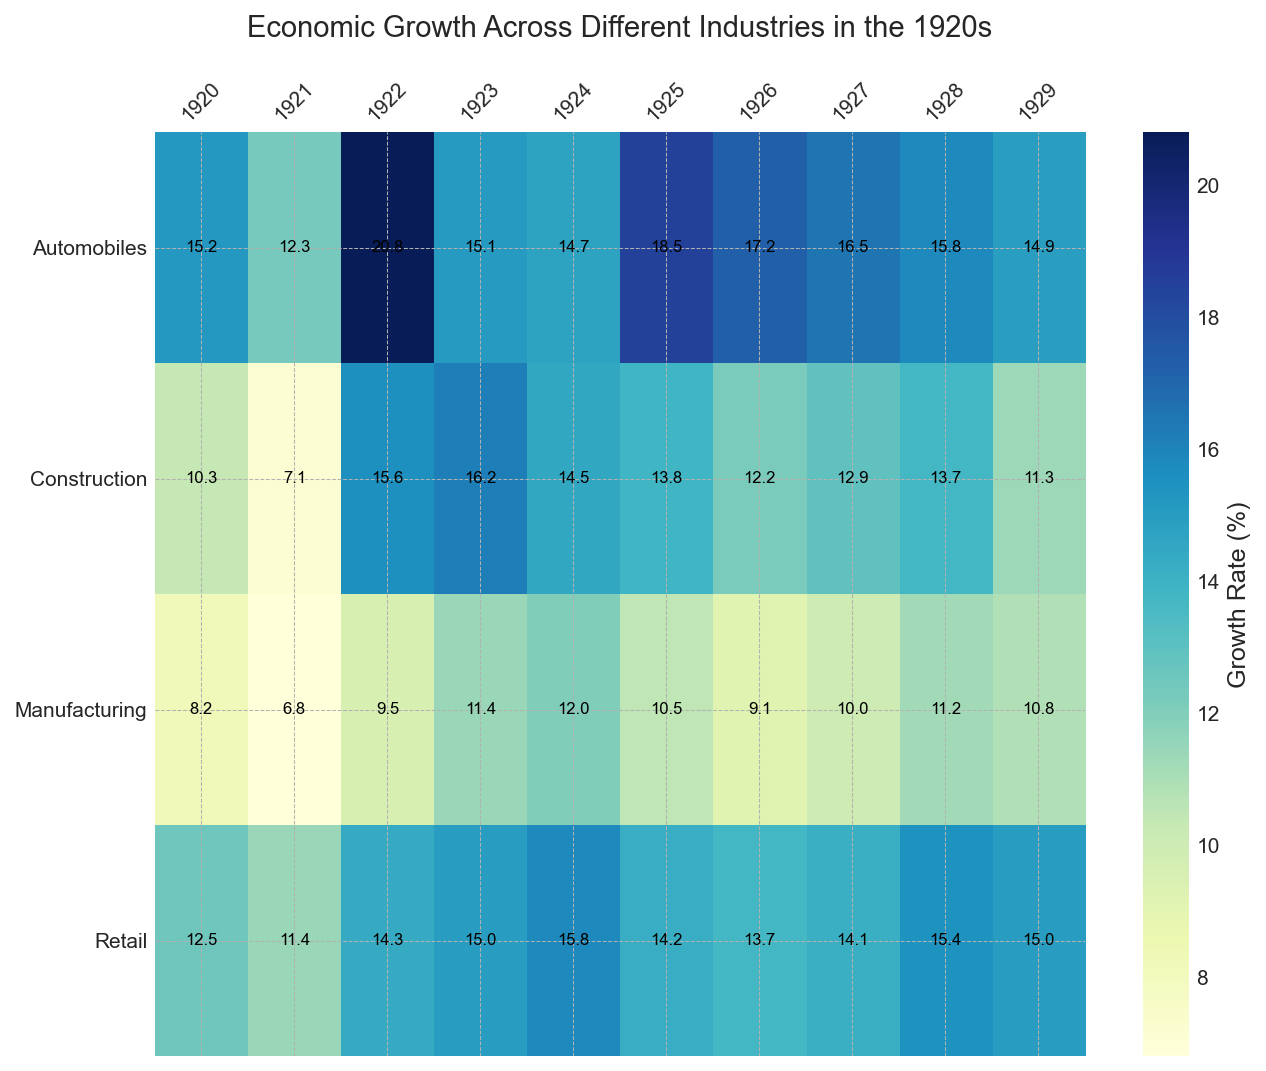Which industry had the highest growth rate in 1923? Look at the 1923 column and find the highest value. The highest growth rate in 1923 is in Construction with 16.2%.
Answer: Construction What was the total growth rate for the Automobiles industry from 1925 to 1929? Sum up the growth rates for the Automobiles industry from 1925 (18.5%) to 1929 (14.9%). The total growth rate is 18.5 + 17.2 + 16.5 + 15.8 + 14.9 = 82.9%.
Answer: 82.9% Which industry had the most consistent growth rate throughout the decade (1920-1929)? Consistency can be evaluated by visually inspecting the variation in color intensity for each industry across the years. The Manufacturing industry's growth rates have the least variation in color intensity.
Answer: Manufacturing What is the average growth rate for the Retail industry during the entire decade? Sum the growth rates for the Retail industry from 1920 to 1929 and divide by the number of years (10). The sum is 12.5 + 11.4 + 14.3 + 15.0 + 15.8 + 14.2 + 13.7 + 14.1 + 15.4 + 15.0 = 141.4. The average is 141.4 / 10 = 14.14%.
Answer: 14.14% Did the Manufacturing industry ever have a higher growth rate than the Construction industry? Compare the yearly growth rates of Manufacturing and Construction industries. In 1924, Manufacturing had a growth rate of 12.0%, while Construction had a growth rate of 14.5%. Hence, Manufacturing never had a higher growth rate.
Answer: No Between 1926 and 1929, which industry had the lowest growth rate in any year? Inspect the growth rates for all industries from 1926 to 1929 and find the minimum value. The lowest growth rate during this period is in Construction in 1929 (11.3%).
Answer: Construction What is the difference in growth rate for the Automobile industry between its highest and lowest year? Identify the highest growth rate (1922, 20.8%) and the lowest growth rate (1921, 12.3%) for the Automobile industry, then calculate the difference. The difference is 20.8 - 12.3 = 8.5%.
Answer: 8.5% How does the average growth rate of the Construction industry in the 1920s compare to the Retail industry's highest single-year growth rate? Calculate the average growth rate for Construction (total of 127.6 over 10 years is 12.76%). Compare it to the Retail’s highest growth rate (15.8% in 1924). The Retail industry's highest single-year growth rate is higher.
Answer: Retail's highest single-year growth rate is higher 